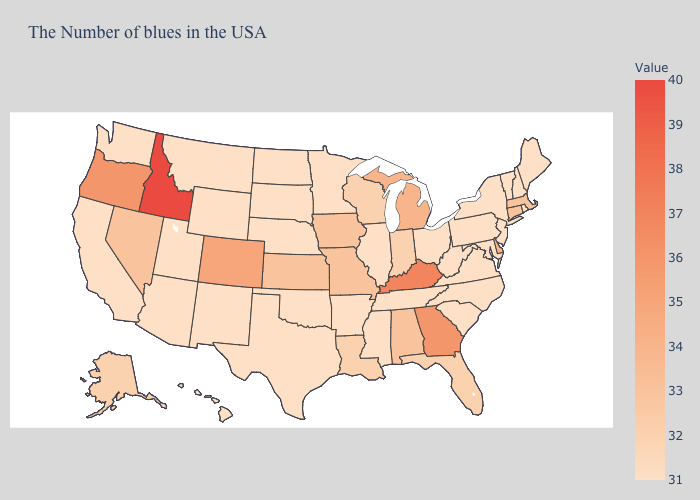Which states hav the highest value in the West?
Give a very brief answer. Idaho. Does Idaho have the highest value in the West?
Answer briefly. Yes. Does Wyoming have the lowest value in the West?
Short answer required. Yes. Which states hav the highest value in the West?
Short answer required. Idaho. Among the states that border Texas , which have the lowest value?
Short answer required. Arkansas, Oklahoma, New Mexico. Among the states that border Florida , does Alabama have the highest value?
Answer briefly. No. Among the states that border Nevada , does Utah have the highest value?
Concise answer only. No. Does the map have missing data?
Answer briefly. No. 